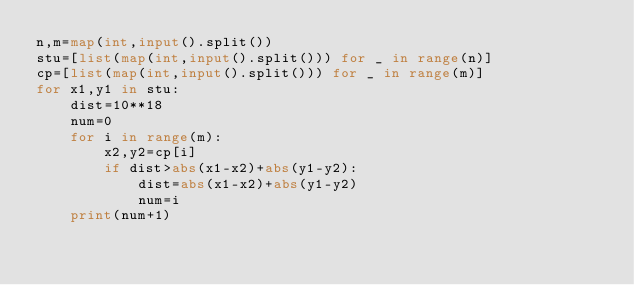<code> <loc_0><loc_0><loc_500><loc_500><_Python_>n,m=map(int,input().split())
stu=[list(map(int,input().split())) for _ in range(n)]
cp=[list(map(int,input().split())) for _ in range(m)]
for x1,y1 in stu:
    dist=10**18
    num=0
    for i in range(m):
        x2,y2=cp[i]
        if dist>abs(x1-x2)+abs(y1-y2):
            dist=abs(x1-x2)+abs(y1-y2)
            num=i
    print(num+1)</code> 